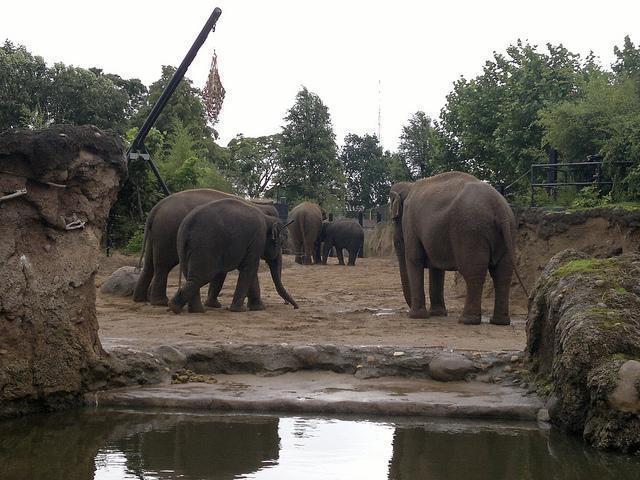How many elephants are there?
Give a very brief answer. 3. 